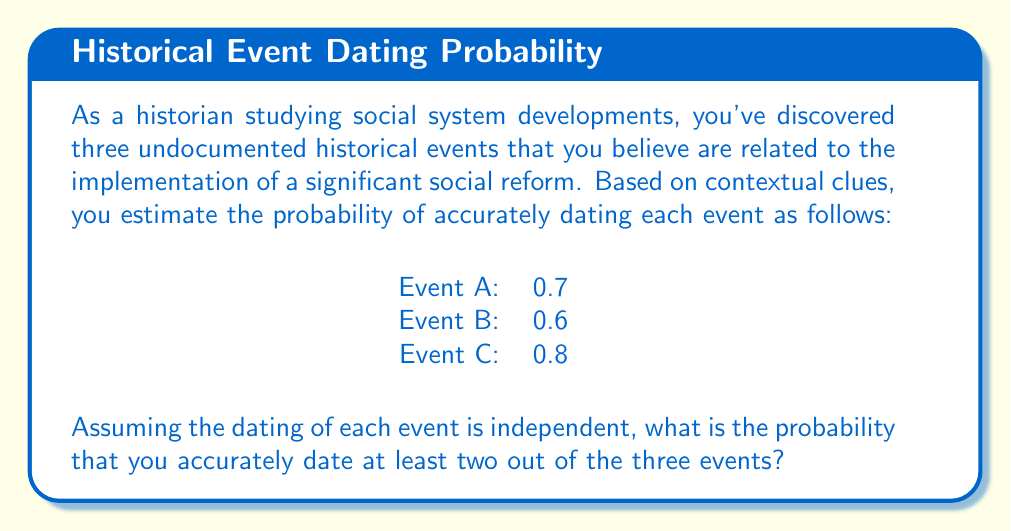Could you help me with this problem? To solve this problem, we need to use the concept of probability for multiple independent events. Let's approach this step-by-step:

1) First, let's define our events:
   $A$: Accurately dating Event A
   $B$: Accurately dating Event B
   $C$: Accurately dating Event C

2) We're looking for the probability of accurately dating at least two events. This can happen in four ways:
   - All three events are accurately dated
   - A and B are accurately dated, C is not
   - A and C are accurately dated, B is not
   - B and C are accurately dated, A is not

3) Let's calculate each of these probabilities:

   P(All three correct) = $P(A) \cdot P(B) \cdot P(C) = 0.7 \cdot 0.6 \cdot 0.8 = 0.336$

   P(A and B correct, C incorrect) = $P(A) \cdot P(B) \cdot (1-P(C)) = 0.7 \cdot 0.6 \cdot 0.2 = 0.084$

   P(A and C correct, B incorrect) = $P(A) \cdot (1-P(B)) \cdot P(C) = 0.7 \cdot 0.4 \cdot 0.8 = 0.224$

   P(B and C correct, A incorrect) = $(1-P(A)) \cdot P(B) \cdot P(C) = 0.3 \cdot 0.6 \cdot 0.8 = 0.144$

4) The total probability is the sum of these individual probabilities:

   $P(\text{at least two correct}) = 0.336 + 0.084 + 0.224 + 0.144 = 0.788$

Therefore, the probability of accurately dating at least two out of the three events is 0.788 or 78.8%.
Answer: 0.788 or 78.8% 